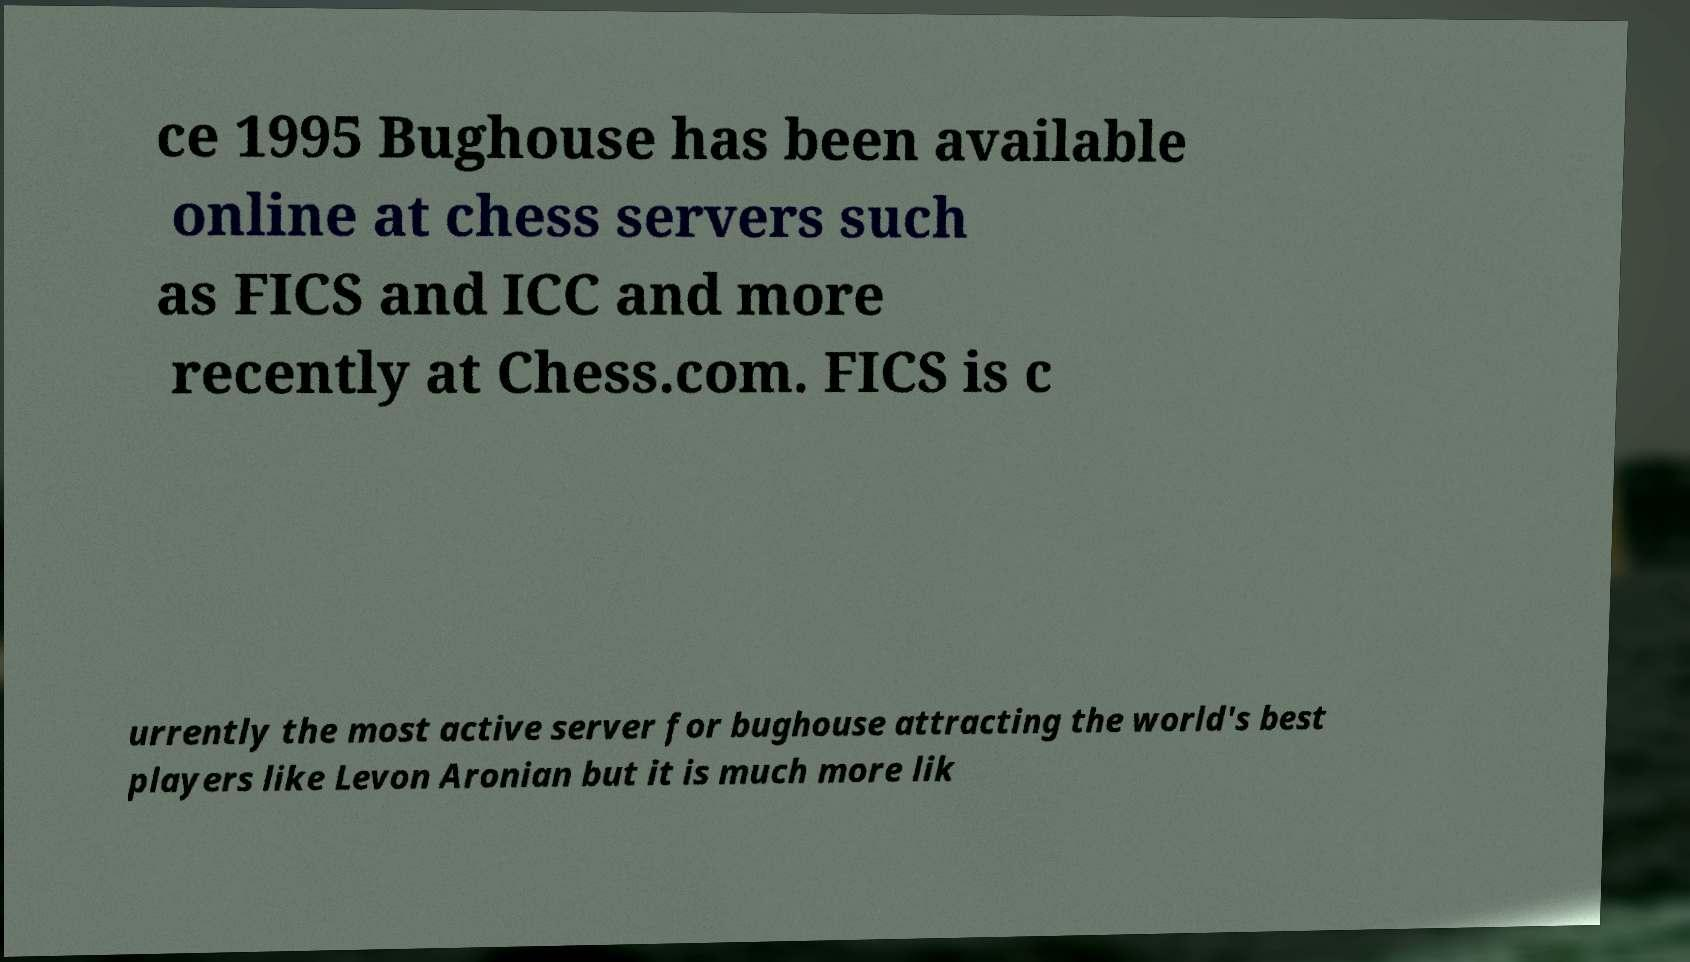Can you read and provide the text displayed in the image?This photo seems to have some interesting text. Can you extract and type it out for me? ce 1995 Bughouse has been available online at chess servers such as FICS and ICC and more recently at Chess.com. FICS is c urrently the most active server for bughouse attracting the world's best players like Levon Aronian but it is much more lik 